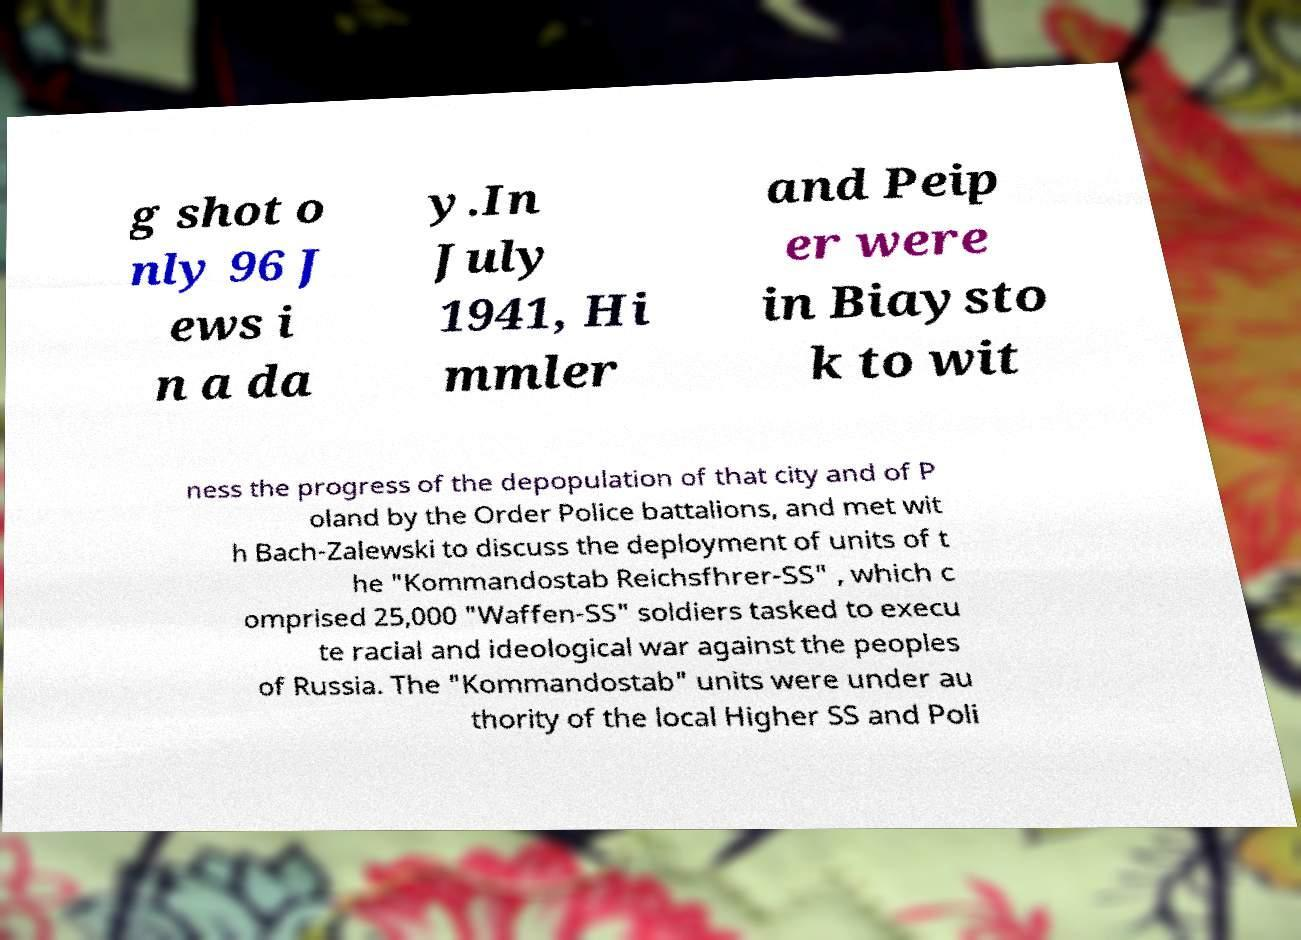For documentation purposes, I need the text within this image transcribed. Could you provide that? g shot o nly 96 J ews i n a da y.In July 1941, Hi mmler and Peip er were in Biaysto k to wit ness the progress of the depopulation of that city and of P oland by the Order Police battalions, and met wit h Bach-Zalewski to discuss the deployment of units of t he "Kommandostab Reichsfhrer-SS" , which c omprised 25,000 "Waffen-SS" soldiers tasked to execu te racial and ideological war against the peoples of Russia. The "Kommandostab" units were under au thority of the local Higher SS and Poli 